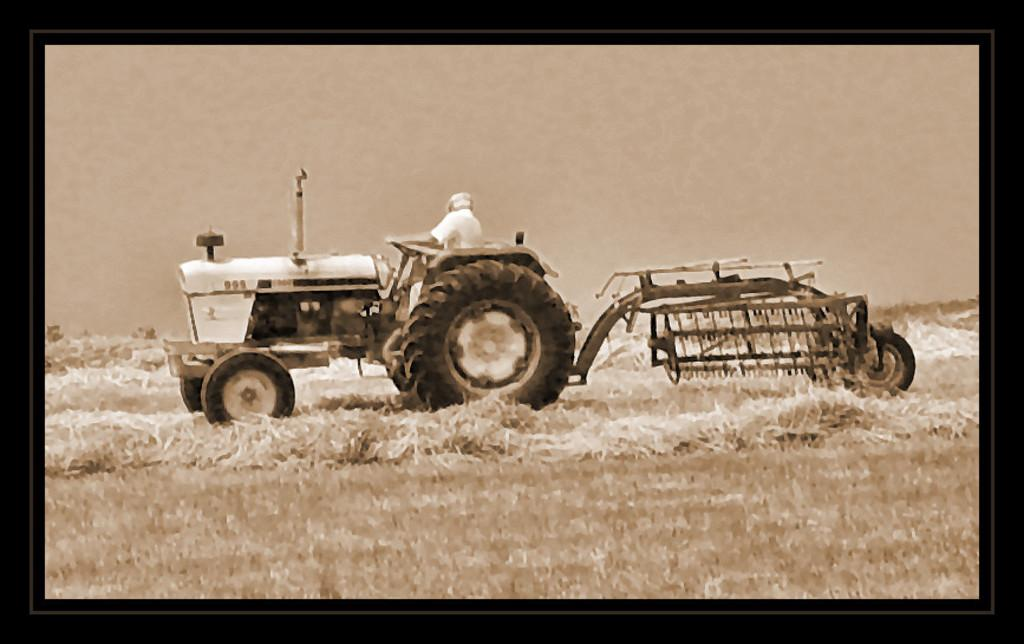What object is present in the image that typically holds a picture? There is a photo frame in the image. What is shown in the photo frame? The photo frame contains a picture. What is the man in the picture doing? The man is ploughing the land in the picture. What type of goldfish can be seen swimming in the photo frame? There are no goldfish present in the image; the photo frame contains a picture of a man sitting on a tractor. 